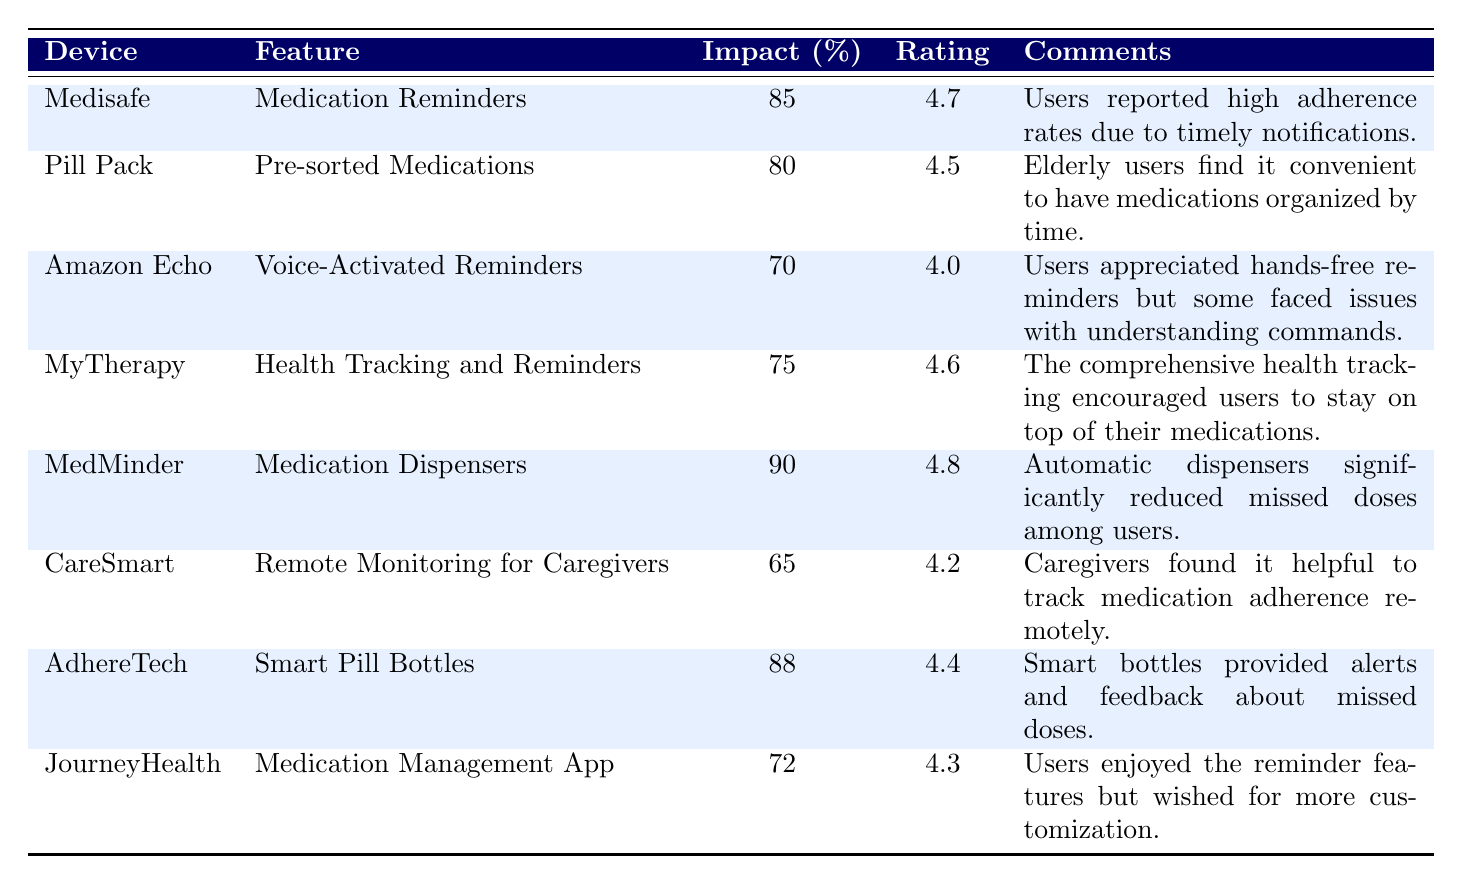What is the user satisfaction rating for the MedMinder device? The table lists the user satisfaction rating for MedMinder as 4.8 out of 5.
Answer: 4.8 What device has the highest impact on adherence? According to the table, MedMinder has the highest impact on adherence at 90%.
Answer: MedMinder Which device combines medication reminders with health tracking? MyTherapy combines health tracking with medication reminders as indicated in the table.
Answer: MyTherapy What is the average impact on adherence for all devices listed? To find the average, add the impacts: 85 + 80 + 70 + 75 + 90 + 65 + 88 + 72 = 720. Then divide by the number of devices, which is 8. Therefore, the average is 720 / 8 = 90.
Answer: 90 Does the CareSmart device have a user satisfaction rating above 4.5? The table shows that CareSmart has a user satisfaction rating of 4.2, which is not above 4.5.
Answer: No Which device offers remote monitoring for caregivers? CareSmart is the device that offers remote monitoring for caregivers as per the table details.
Answer: CareSmart What percentage lower is the impact on adherence of the Amazon Echo compared to MedMinder? The impact on adherence for Amazon Echo is 70% and for MedMinder, it is 90%. The difference is 90 - 70 = 20%.
Answer: 20% Which devices have an impact on adherence below 75%? The devices with an impact below 75% are Amazon Echo (70%) and CareSmart (65%).
Answer: Amazon Echo and CareSmart How do the user satisfaction ratings compare between Pill Pack and AdhereTech? Pill Pack has a rating of 4.5 while AdhereTech has a rating of 4.4. Therefore, Pill Pack's rating is higher by 0.1.
Answer: Pill Pack has a higher rating What is the relationship between impact on adherence and user satisfaction? To analyze the relationship, we can compare the data columns: generally, devices with higher impact on adherence also have comparable user satisfaction ratings, suggesting a positive correlation. For example, MedMinder (90%, 4.8) and Medisafe (85%, 4.7) both show high ratings.
Answer: Positive correlation observed 